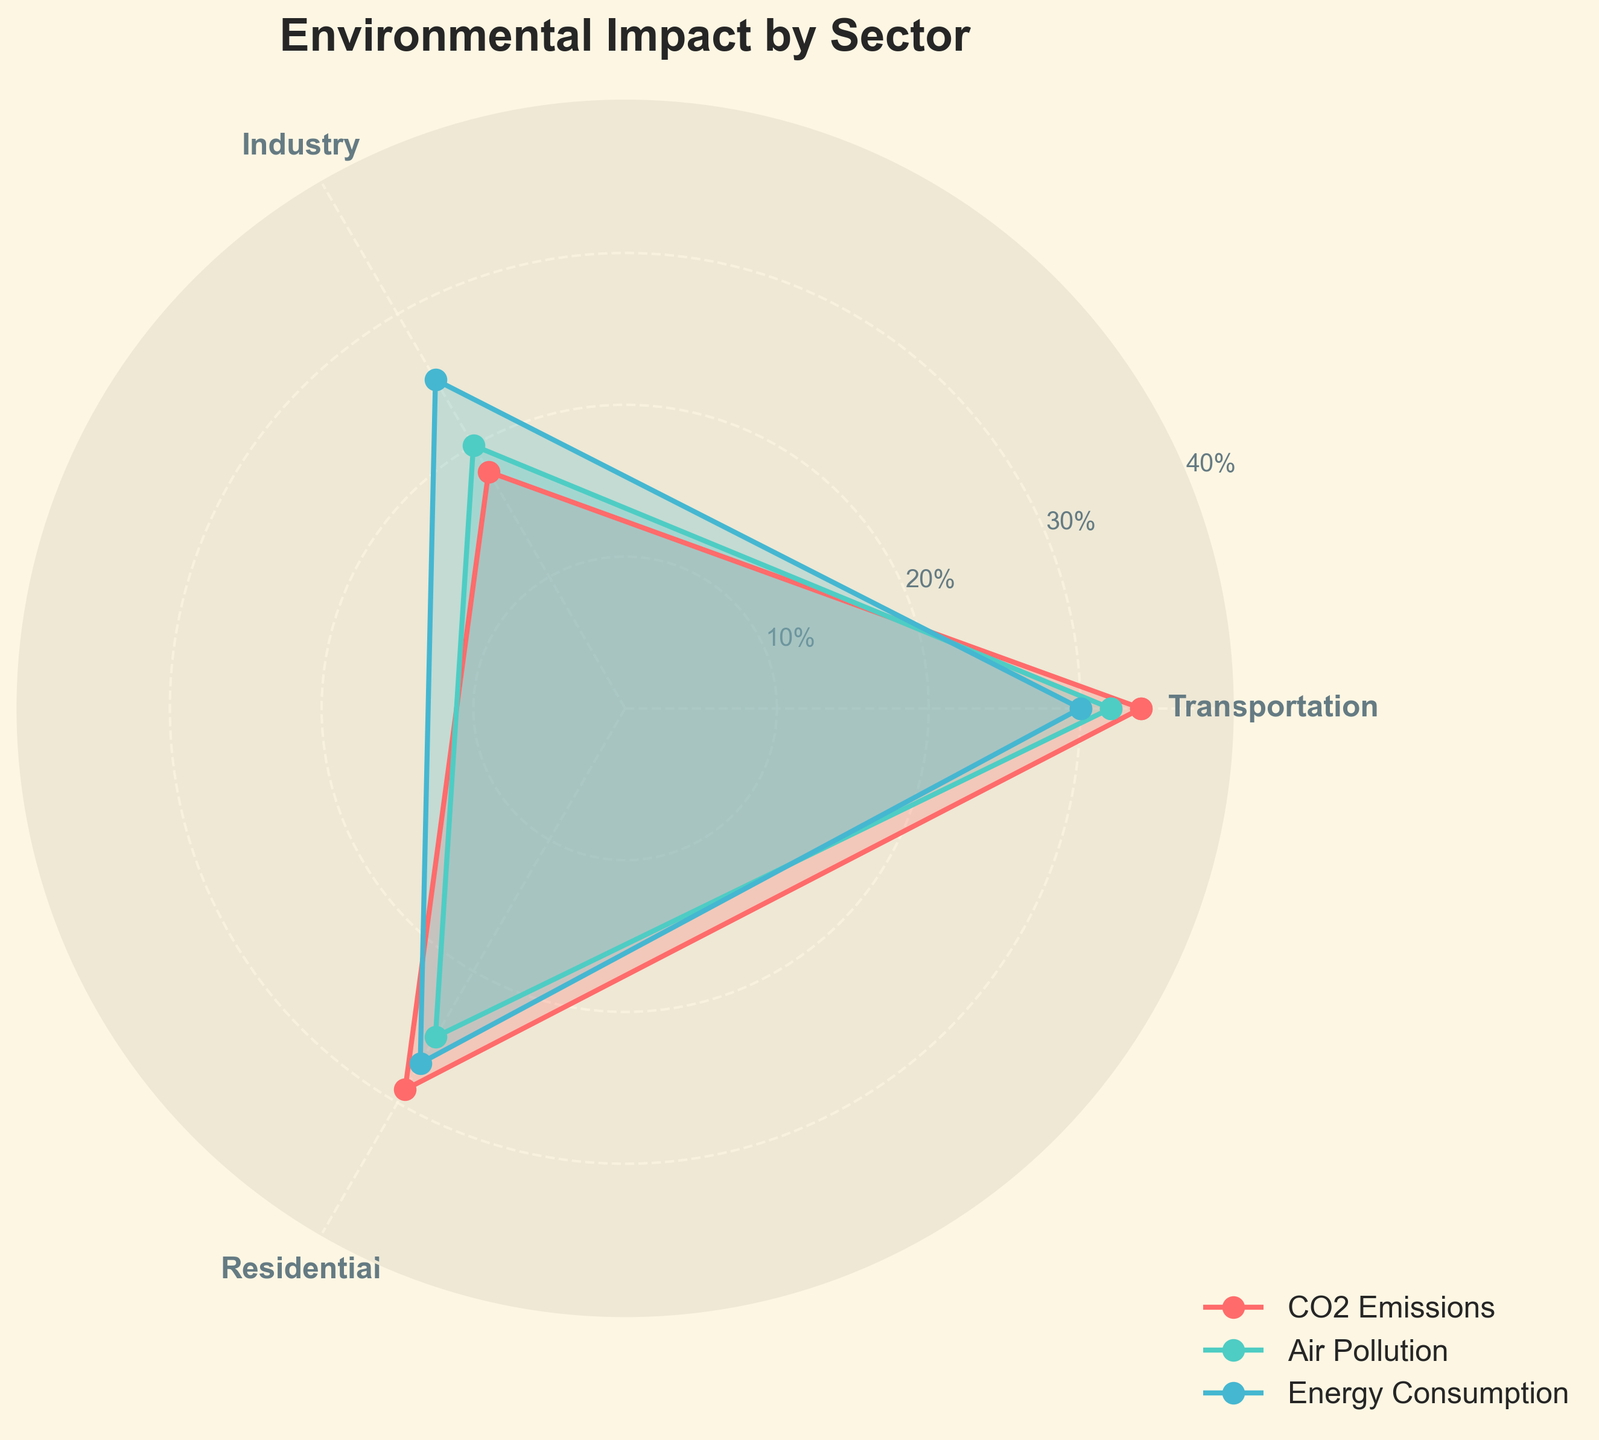What is the title of the figure? The title of the figure is prominently displayed at the top. It reads "Environmental Impact by Sector."
Answer: Environmental Impact by Sector Which sector has the highest CO2 emissions? By looking at the figure, we can see the value for CO2 emissions is highest for the Industry sector.
Answer: Industry What is the overall range of percentages used for the y-axis? The y-axis displays percentages ranging from 10% to 40%. This can be seen from the tick marks on the y-axis.
Answer: 10% to 40% Which type of environmental impact has the highest percentage in the Residential sector? In the figure, for the Residential sector, we compare the three types of impact and see that Energy Consumption has the highest percentage.
Answer: Energy Consumption Compare CO2 emissions between the Transportation and Residential sectors. Which one is higher and by how much? The CO2 emissions for the Transportation sector is 25%, and for the Residential sector, it's 20%. The difference is 25% - 20% = 5%.
Answer: Transportation, 5% What is the average percentage of Air Pollution across all sectors? The Air Pollution percentages are 29% (Transportation), 34% (Industry), and 18% (Residential). The average is (29 + 34 + 18) / 3 = 27%.
Answer: 27% How does the Energy Consumption percentage of the Transportation sector compare to that of the Industry sector? The Energy Consumption percentage for the Transportation sector is 27% and for the Industry sector is 30%. The comparison shows that the value for Industry is higher by 30% - 27% = 3%.
Answer: Industry, 3% Which sector appears at the first angle in the rose chart? The first sector that appears at the initial angle (starting position) in the rose chart is Transportation.
Answer: Transportation Which sector has the smallest range of percentages across all environmental impact types? By visual inspection, the Residential sector has percentages of 20%, 18%, and 25%, which makes the range 25% - 18% = 7%. This is the smallest range compared to other sectors.
Answer: Residential What is the combined percentage of CO2 emissions and Energy Consumption for the Industry sector? The CO2 emissions for Industry is 32% and Energy Consumption is 30%. Their combined value is 32% + 30% = 62%.
Answer: 62% 